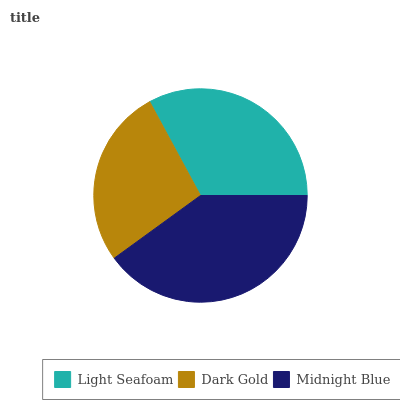Is Dark Gold the minimum?
Answer yes or no. Yes. Is Midnight Blue the maximum?
Answer yes or no. Yes. Is Midnight Blue the minimum?
Answer yes or no. No. Is Dark Gold the maximum?
Answer yes or no. No. Is Midnight Blue greater than Dark Gold?
Answer yes or no. Yes. Is Dark Gold less than Midnight Blue?
Answer yes or no. Yes. Is Dark Gold greater than Midnight Blue?
Answer yes or no. No. Is Midnight Blue less than Dark Gold?
Answer yes or no. No. Is Light Seafoam the high median?
Answer yes or no. Yes. Is Light Seafoam the low median?
Answer yes or no. Yes. Is Midnight Blue the high median?
Answer yes or no. No. Is Midnight Blue the low median?
Answer yes or no. No. 